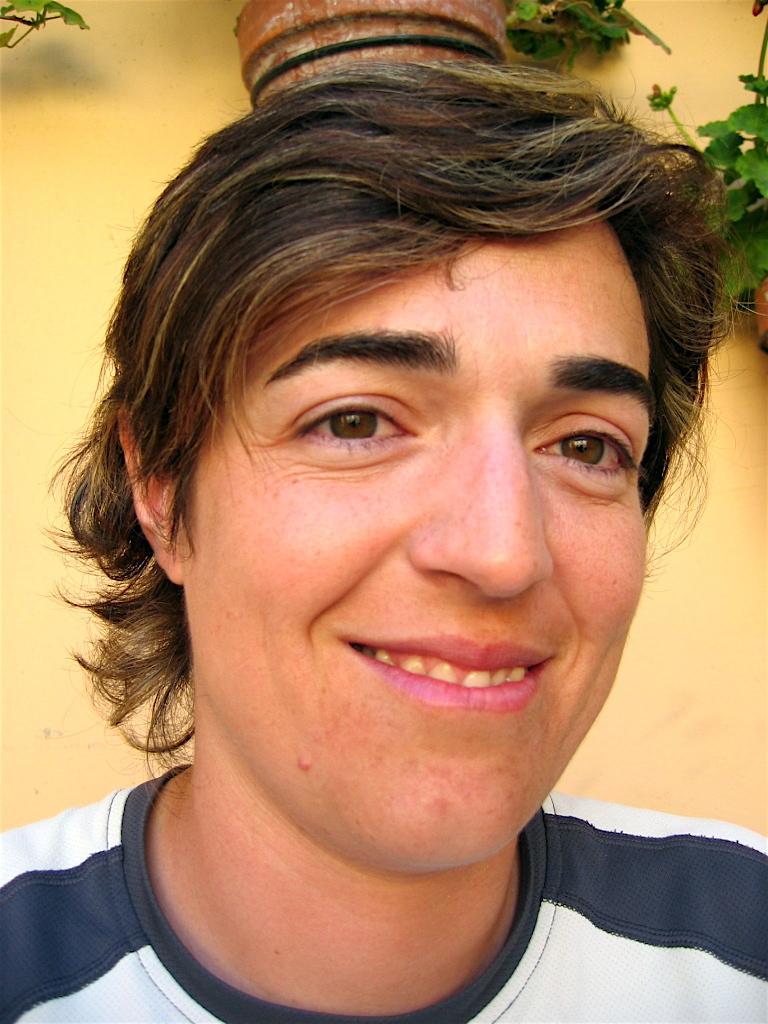In one or two sentences, can you explain what this image depicts? In this image we can see one person with a smiling face near the wall, two pots with plants attached to the wall and some leaves with stems on the top left side corner of the image. 